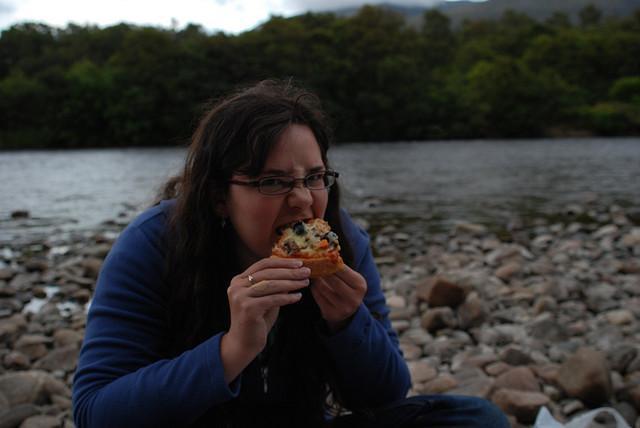How many elephant that is standing do you see?
Give a very brief answer. 0. 